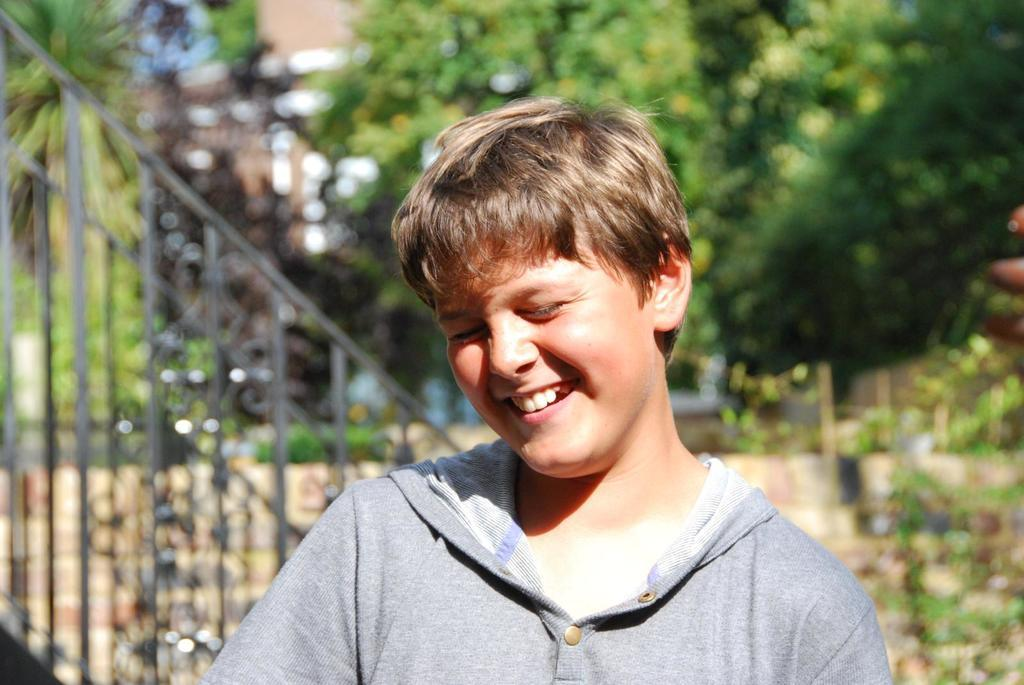Who is present in the picture? There is a boy in the picture. What is the boy's expression in the picture? The boy is smiling in the picture. What can be seen in the background of the picture? There are trees in the background of the picture. What type of juice is the boy holding in the picture? There is no juice present in the picture; the boy is not holding any object. 